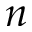<formula> <loc_0><loc_0><loc_500><loc_500>n</formula> 